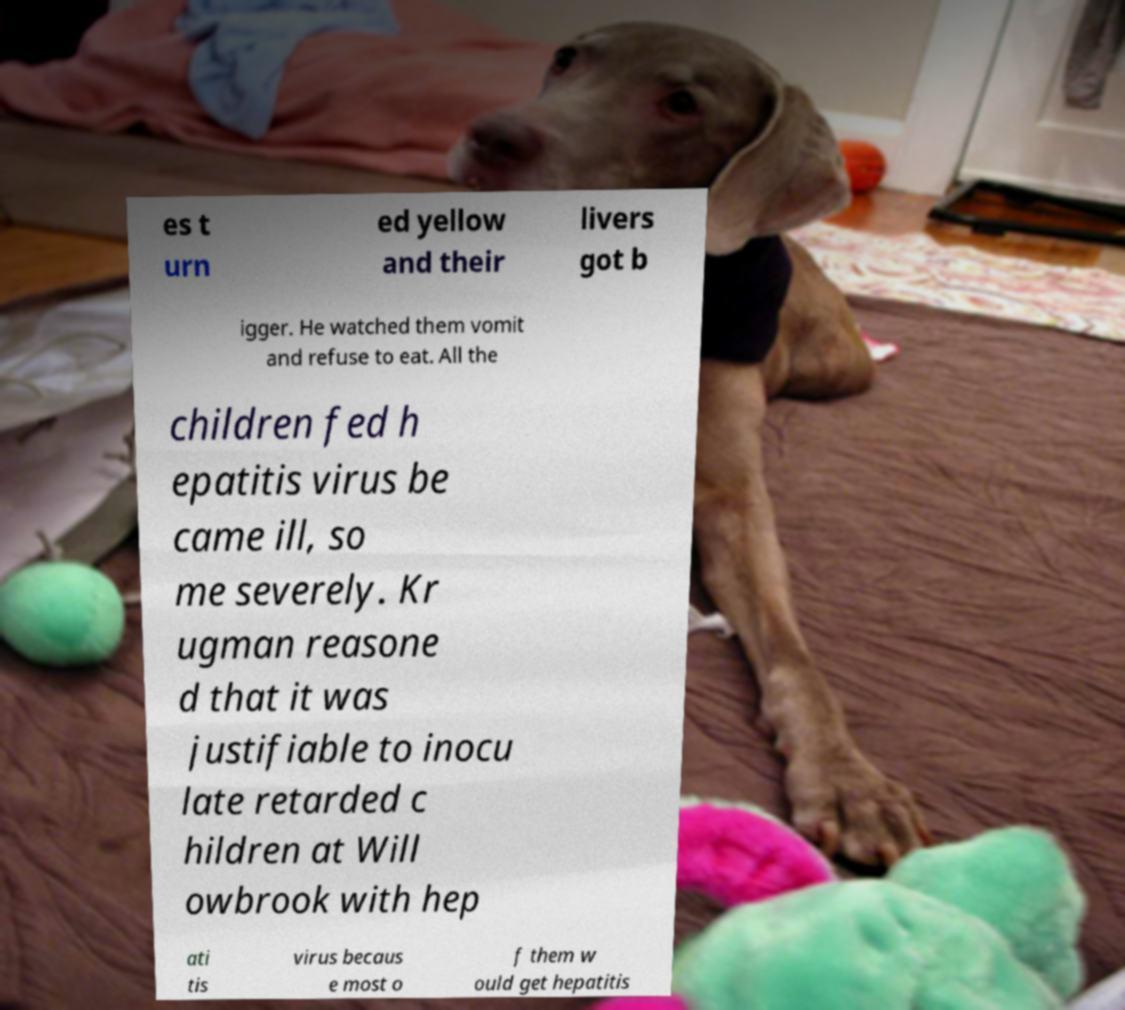Please read and relay the text visible in this image. What does it say? es t urn ed yellow and their livers got b igger. He watched them vomit and refuse to eat. All the children fed h epatitis virus be came ill, so me severely. Kr ugman reasone d that it was justifiable to inocu late retarded c hildren at Will owbrook with hep ati tis virus becaus e most o f them w ould get hepatitis 